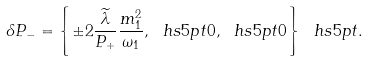Convert formula to latex. <formula><loc_0><loc_0><loc_500><loc_500>\delta P _ { - } = \left \{ \pm 2 \frac { \widetilde { \lambda } } { P _ { + } } \frac { m _ { 1 } ^ { 2 } } { \omega _ { 1 } } , \ h s { 5 p t } 0 , \ h s { 5 p t } 0 \right \} \ h s { 5 p t } .</formula> 